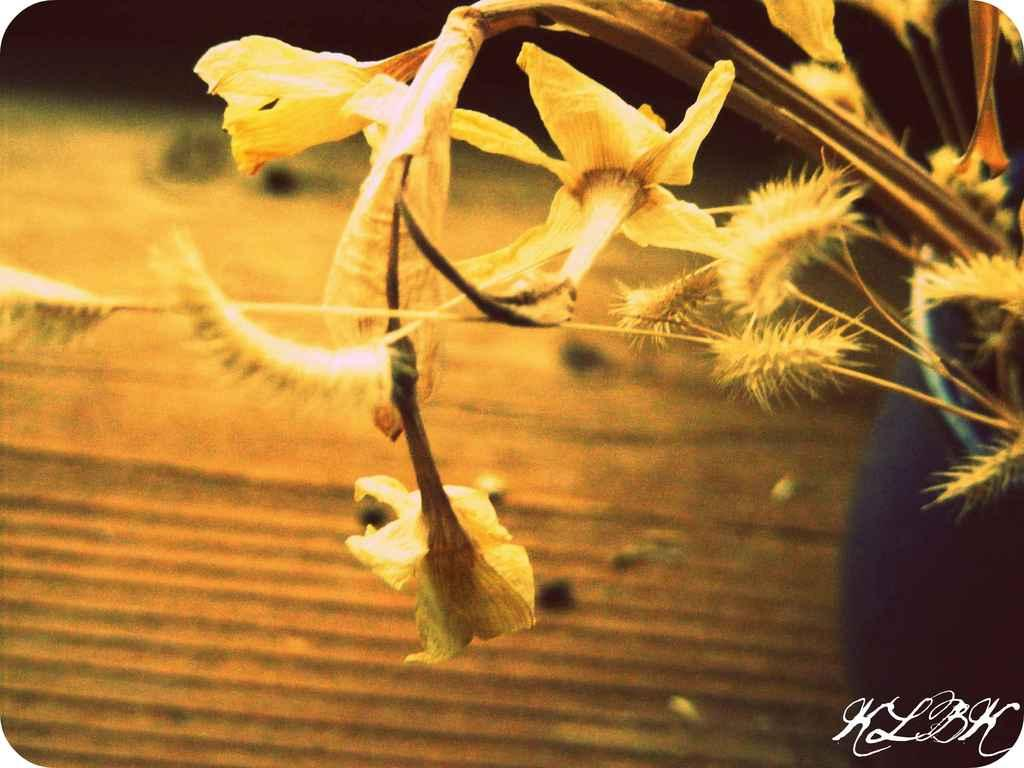What type of living organisms are present in the image? There are flowers in the image. What do the flowers belong to? The flowers belong to a plant. Where is the flower pot located in the image? The flower pot is to the right of the image. What can be observed about the background of the image? The background of the image is blurry. What is present in the bottom right corner of the image? There is text in the bottom right corner of the image. What type of boot is visible in the image? There is no boot present in the image; it features flowers, a plant, and a flower pot. What story is being told by the flowers in the image? The flowers in the image are not telling a story; they are simply part of a plant. 